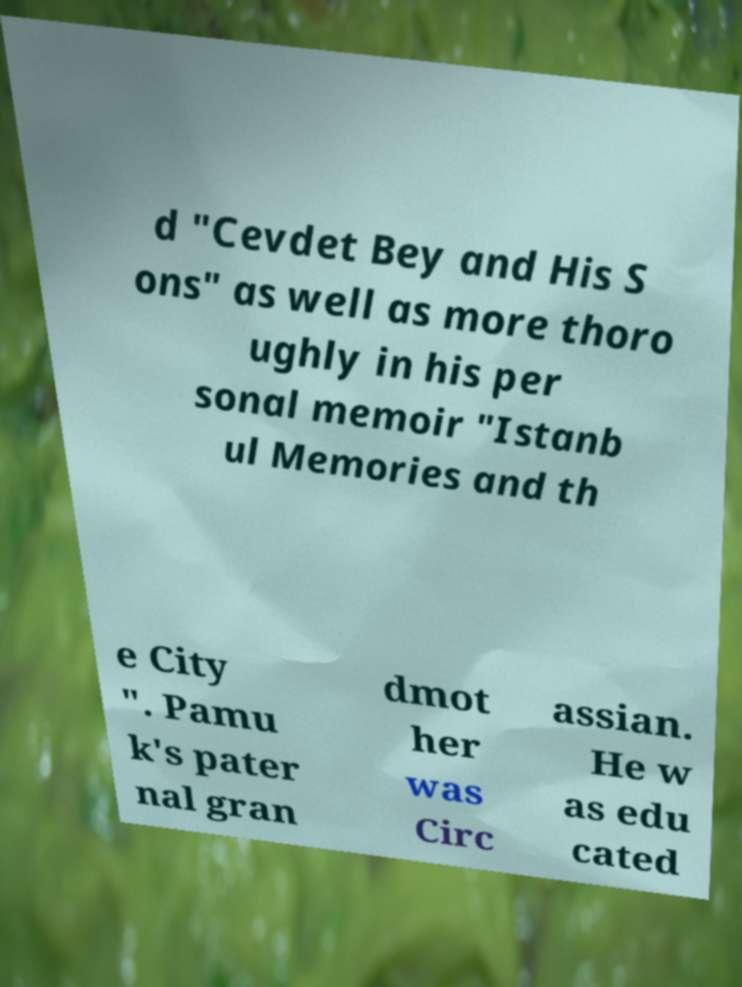Could you assist in decoding the text presented in this image and type it out clearly? d "Cevdet Bey and His S ons" as well as more thoro ughly in his per sonal memoir "Istanb ul Memories and th e City ". Pamu k's pater nal gran dmot her was Circ assian. He w as edu cated 